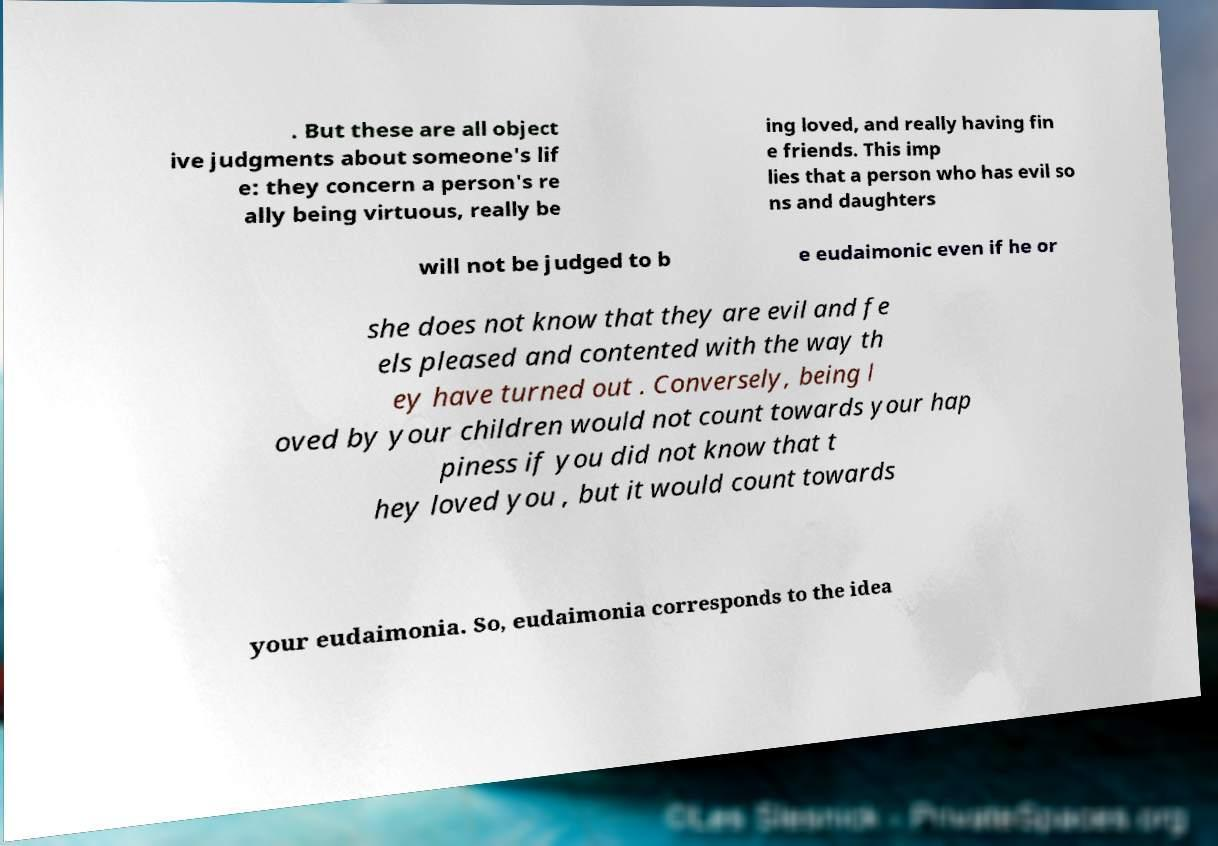Could you assist in decoding the text presented in this image and type it out clearly? . But these are all object ive judgments about someone's lif e: they concern a person's re ally being virtuous, really be ing loved, and really having fin e friends. This imp lies that a person who has evil so ns and daughters will not be judged to b e eudaimonic even if he or she does not know that they are evil and fe els pleased and contented with the way th ey have turned out . Conversely, being l oved by your children would not count towards your hap piness if you did not know that t hey loved you , but it would count towards your eudaimonia. So, eudaimonia corresponds to the idea 